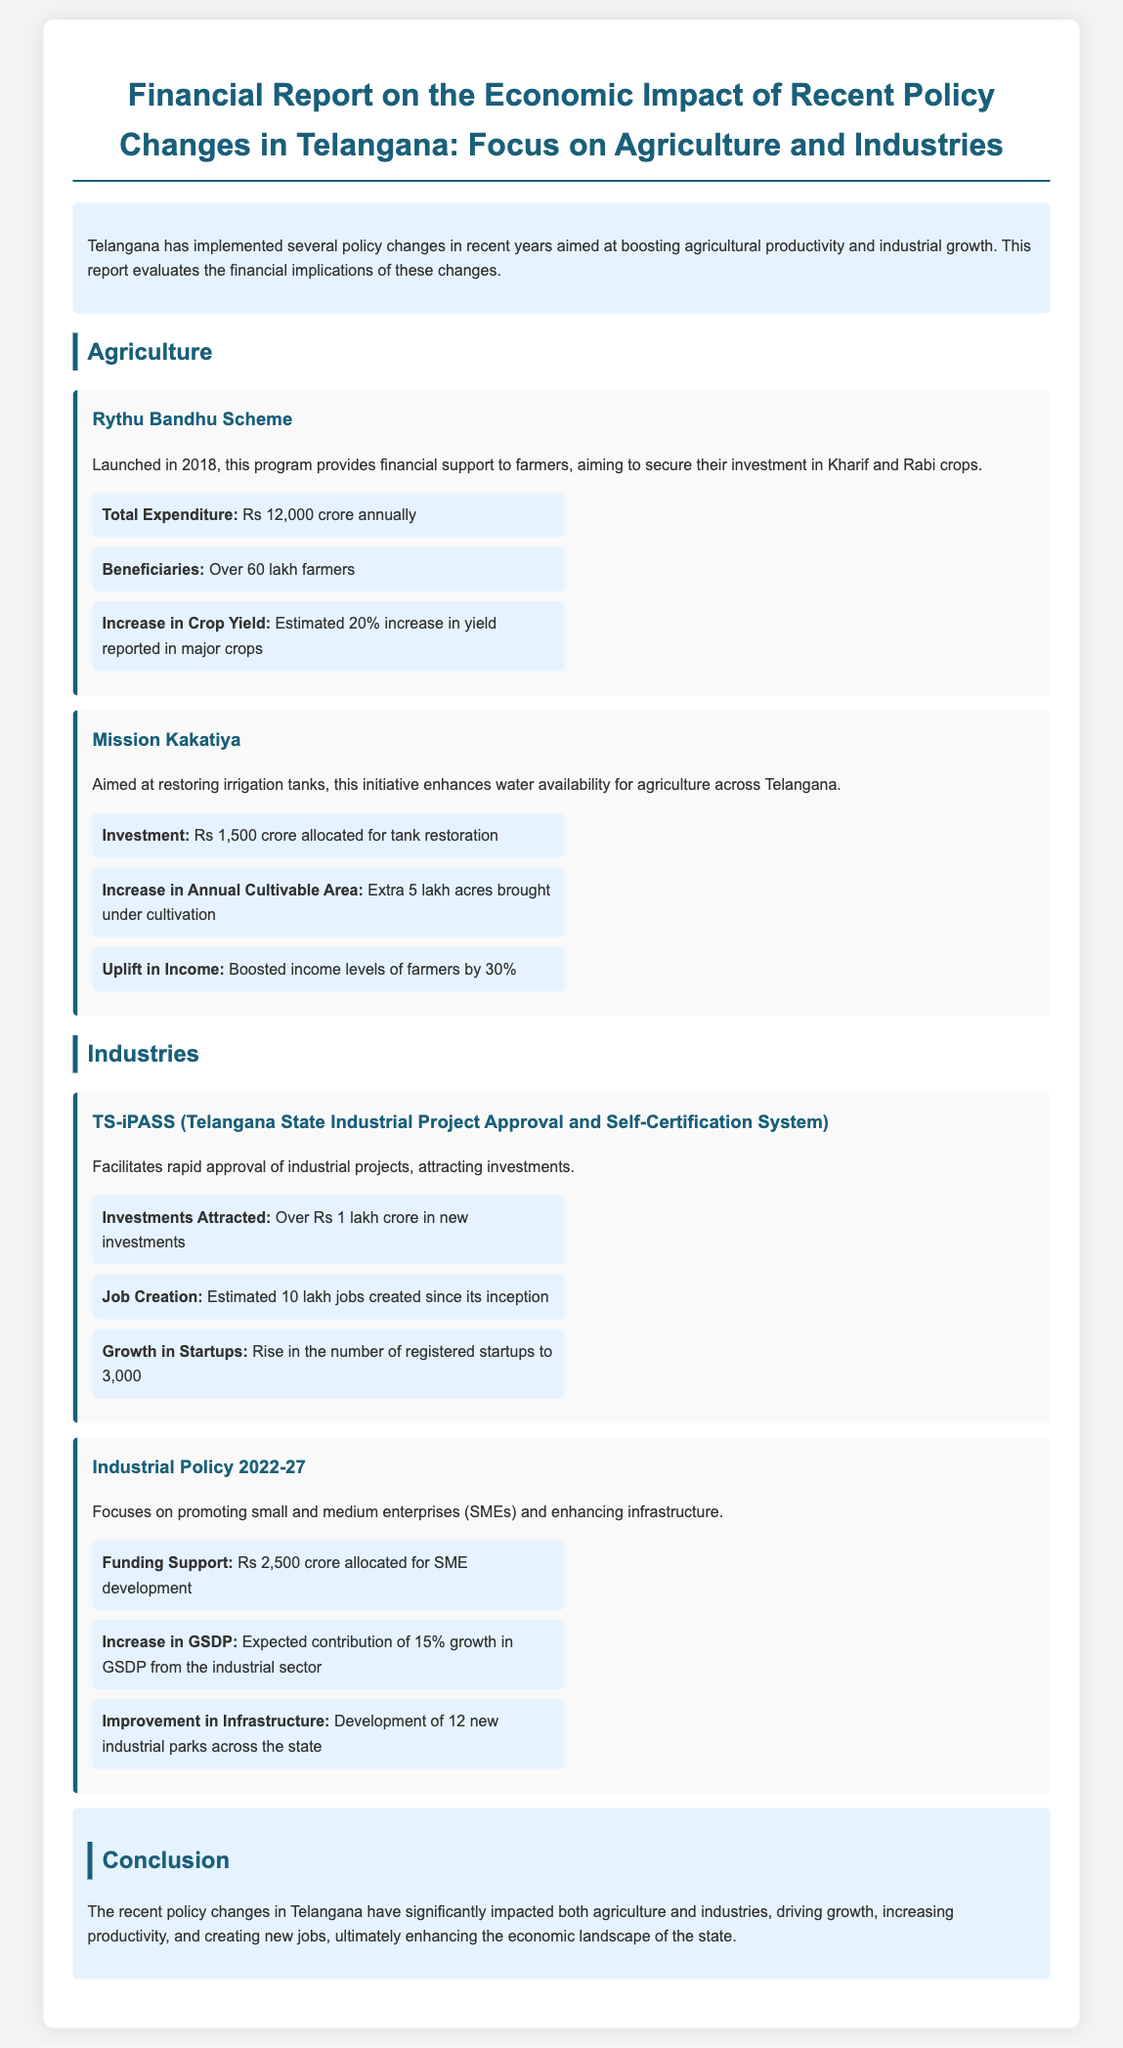What is the total expenditure of the Rythu Bandhu Scheme? The total expenditure is specifically stated in relation to the Rythu Bandhu Scheme, which is Rs 12,000 crore annually.
Answer: Rs 12,000 crore annually How many lakh farmers are beneficiaries of the Rythu Bandhu Scheme? The document mentions that over 60 lakh farmers are beneficiaries of this scheme.
Answer: Over 60 lakh farmers What is the increase in crop yield due to the Rythu Bandhu Scheme? The report estimates a 20% increase in yield reported in major crops as a result of the Rythu Bandhu Scheme.
Answer: 20% What is the estimated investment for the Mission Kakatiya initiative? The investment mentioned for the Mission Kakatiya initiative is Rs 1,500 crore allocated for tank restoration.
Answer: Rs 1,500 crore How many jobs have been created since the inception of TS-iPASS? The document states that estimated 10 lakh jobs have been created since the inception of TS-iPASS.
Answer: 10 lakh jobs What percentage growth in GSDP is expected from the Industrial Policy 2022-27? The Industrial Policy report indicates an expected contribution of 15% growth in GSDP from the industrial sector.
Answer: 15% How many new industrial parks are being developed under the Industrial Policy 2022-27? The report specifies that the development of 12 new industrial parks is part of the initiative.
Answer: 12 What is the total amount allocated for SME development? The document mentions that Rs 2,500 crore has been allocated for SME development according to the Industrial Policy.
Answer: Rs 2,500 crore What is the rise in the number of registered startups due to the TS-iPASS? The document indicates a rise in the number of registered startups to 3,000.
Answer: 3,000 